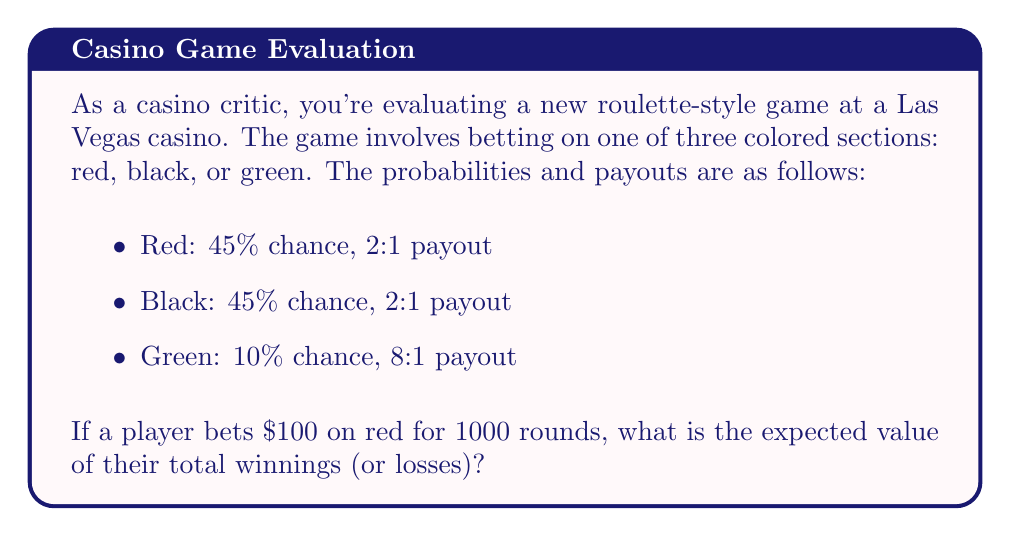Solve this math problem. Let's approach this step-by-step:

1) First, we need to calculate the expected value (EV) for a single $100 bet on red.

2) For red:
   Probability of winning = 45% = 0.45
   Payout if win = 2:1, meaning you get your $100 back plus $200
   Probability of losing = 55% = 0.55 (all other outcomes)

3) The expected value formula is:
   $$EV = (P_{win} \times \text{Win Amount}) + (P_{lose} \times \text{Loss Amount})$$

4) Plugging in our values:
   $$EV = (0.45 \times $200) + (0.55 \times -$100)$$
   $$EV = $90 - $55 = $35$$

5) This means on average, for each $100 bet on red, the player expects to lose $35.

6) For 1000 rounds, we multiply this expected loss by 1000:
   $$\text{Total EV} = 1000 \times (-$35) = -$35,000$$

Therefore, over 1000 rounds of betting $100 on red each time, the player can expect to lose $35,000 on average.
Answer: $-35,000 